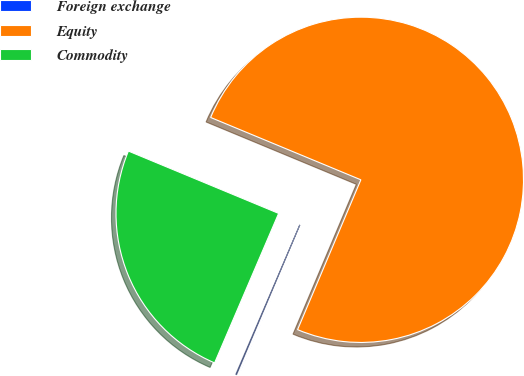<chart> <loc_0><loc_0><loc_500><loc_500><pie_chart><fcel>Foreign exchange<fcel>Equity<fcel>Commodity<nl><fcel>0.08%<fcel>75.1%<fcel>24.82%<nl></chart> 